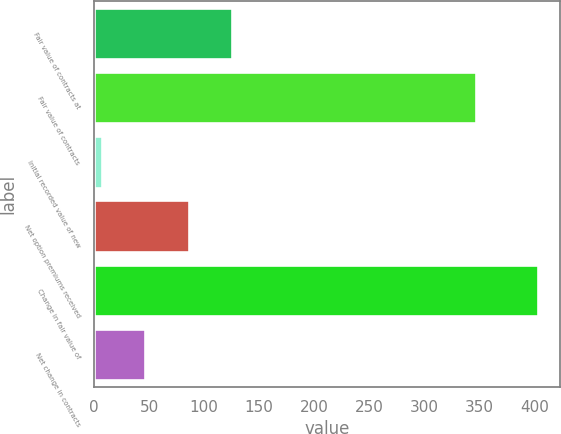Convert chart. <chart><loc_0><loc_0><loc_500><loc_500><bar_chart><fcel>Fair value of contracts at<fcel>Fair value of contracts<fcel>Initial recorded value of new<fcel>Net option premiums received<fcel>Change in fair value of<fcel>Net change in contracts<nl><fcel>125.8<fcel>347<fcel>7<fcel>86.2<fcel>403<fcel>46.6<nl></chart> 